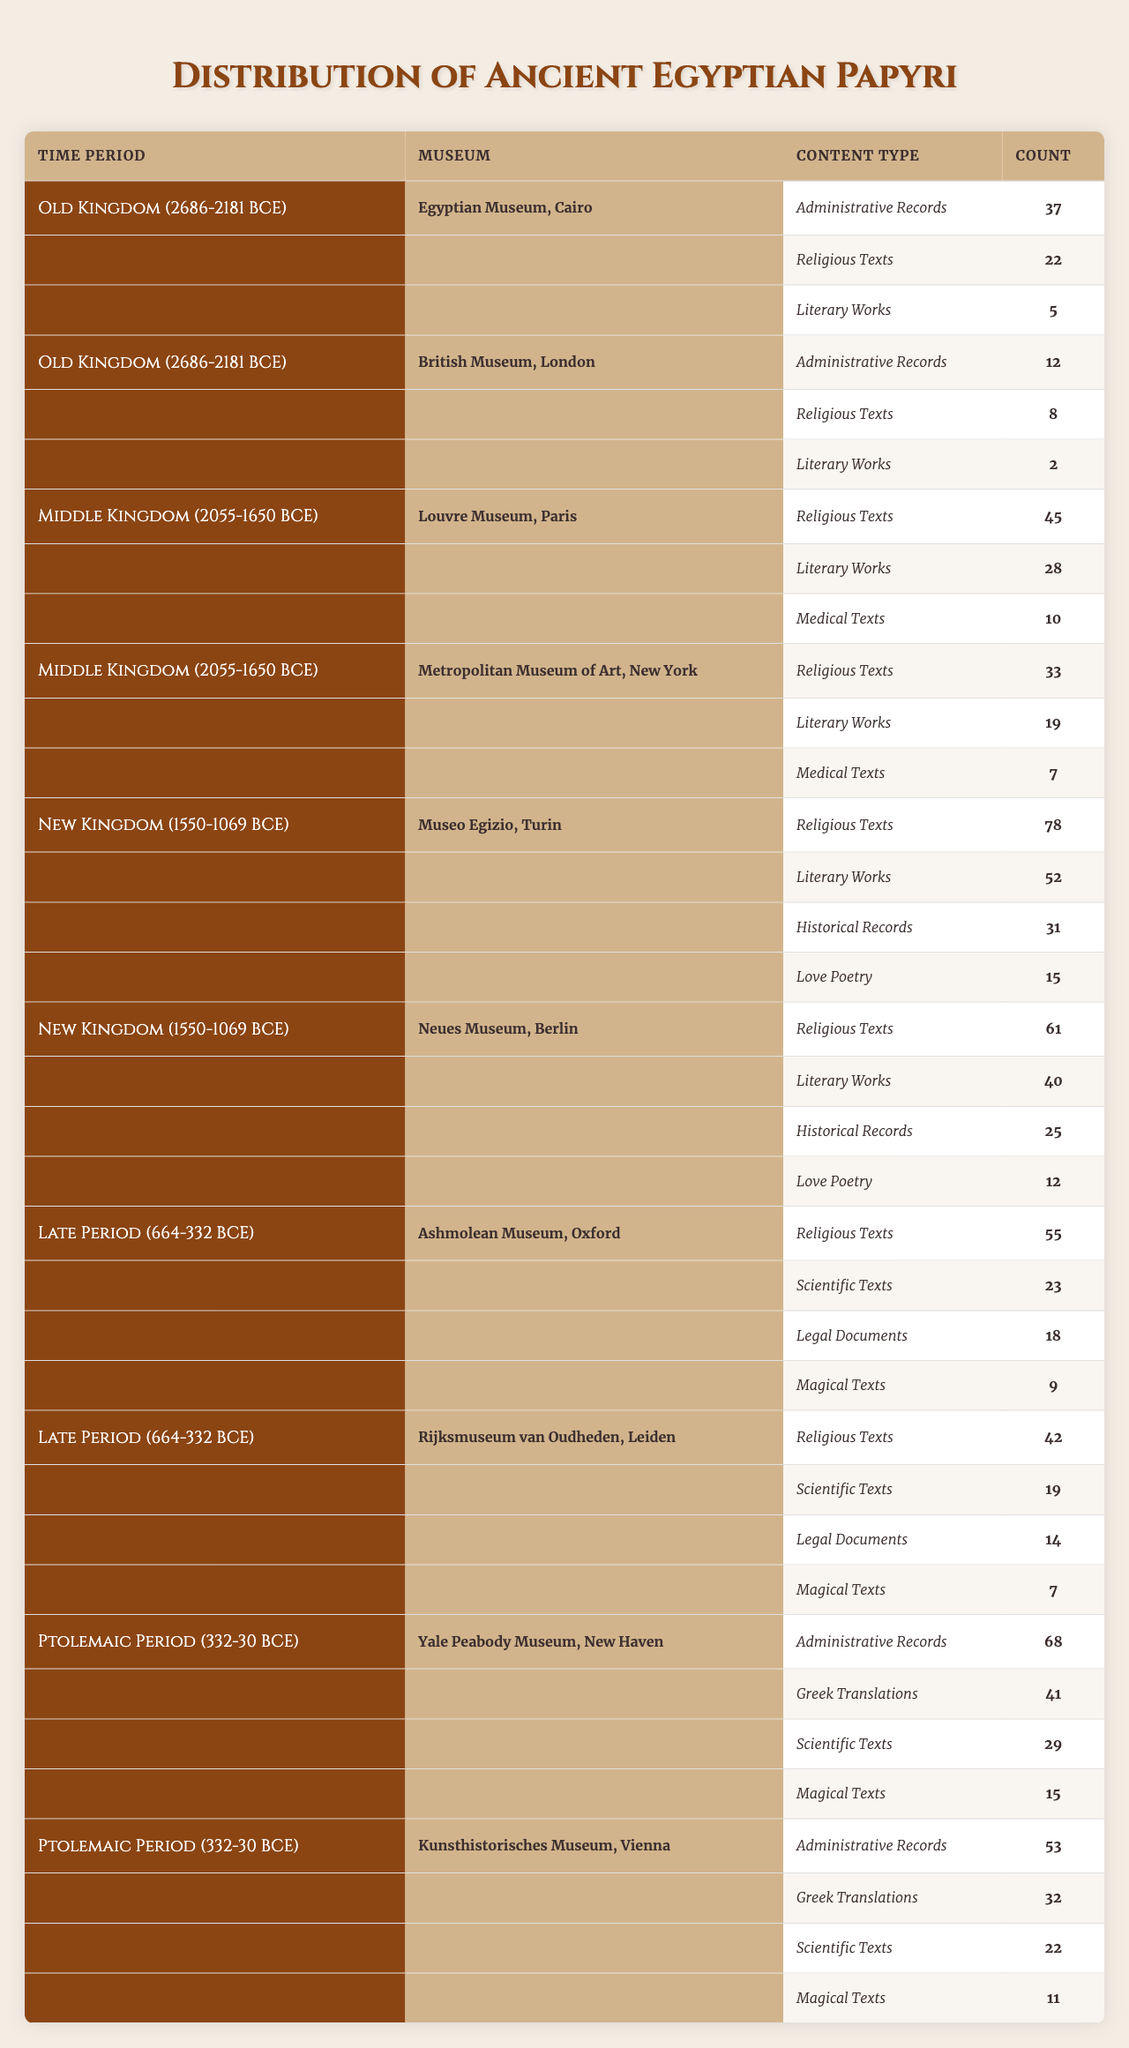What is the total count of administrative records from all museums in the Old Kingdom period? The Egyptian Museum, Cairo has 37 administrative records and the British Museum, London has 12. Therefore, the total count is 37 + 12 = 49.
Answer: 49 Which museum has the highest number of literary works from the New Kingdom period? Museo Egizio, Turin has 52 literary works, whereas Neues Museum, Berlin has 40. Thus, the highest count is from Museo Egizio, Turin.
Answer: Museo Egizio, Turin How many more religious texts does the Louvre Museum have compared to the Metropolitan Museum of Art in the Middle Kingdom period? The Louvre Museum has 45 religious texts and the Metropolitan Museum has 33. The difference is 45 - 33 = 12.
Answer: 12 Are there any magical texts listed in the distribution for the Old Kingdom? The Old Kingdom data shows no magical texts; both museums only have administrative records, religious texts, and literary works. Thus, the answer is no.
Answer: No What is the total count of content types for the Late Period across both museums? The Ashmolean Museum has (55 religious + 23 scientific + 18 legal + 9 magical) = 105, while Rijksmuseum van Oudheden has (42 religious + 19 scientific + 14 legal + 7 magical) = 82. Adding these gives 105 + 82 = 187 total content types.
Answer: 187 Which content type in the New Kingdom has the second highest count overall? Adding the counts of religious texts (78 + 61 = 139), literary works (52 + 40 = 92), historical records (31 + 25 = 56), and love poetry (15 + 12 = 27), the second highest count is from literary works with 92.
Answer: 92 What percentage of the total count of papyri does the Ashmolean Museum hold from the Late Period? The total count for the Late Period (Ashmolean: 105, Rijksmuseum: 82) is 187. The Ashmolean has 105 papyri. So, (105 / 187) * 100 ≈ 56.24%.
Answer: Approximately 56.24% Which time period contains the greatest variety of content types, and how many types are there? The New Kingdom has the following content types: religious texts, literary works, historical records, and love poetry—totaling 4 content types. This is more than the other periods that have fewer types.
Answer: New Kingdom, 4 types Is the count of Greek translations in the Ptolemaic Period higher than the count of love poetry in the New Kingdom? The Ptolemaic Period has 41 Greek translations, while the New Kingdom has 15 love poetry. Since 41 > 15, the answer is yes.
Answer: Yes What is the combined count of medical texts in the Middle Kingdom period across both museums? The Louvre Museum has 10 medical texts and the Metropolitan Museum of Art has 7. The combined count is 10 + 7 = 17 medical texts.
Answer: 17 